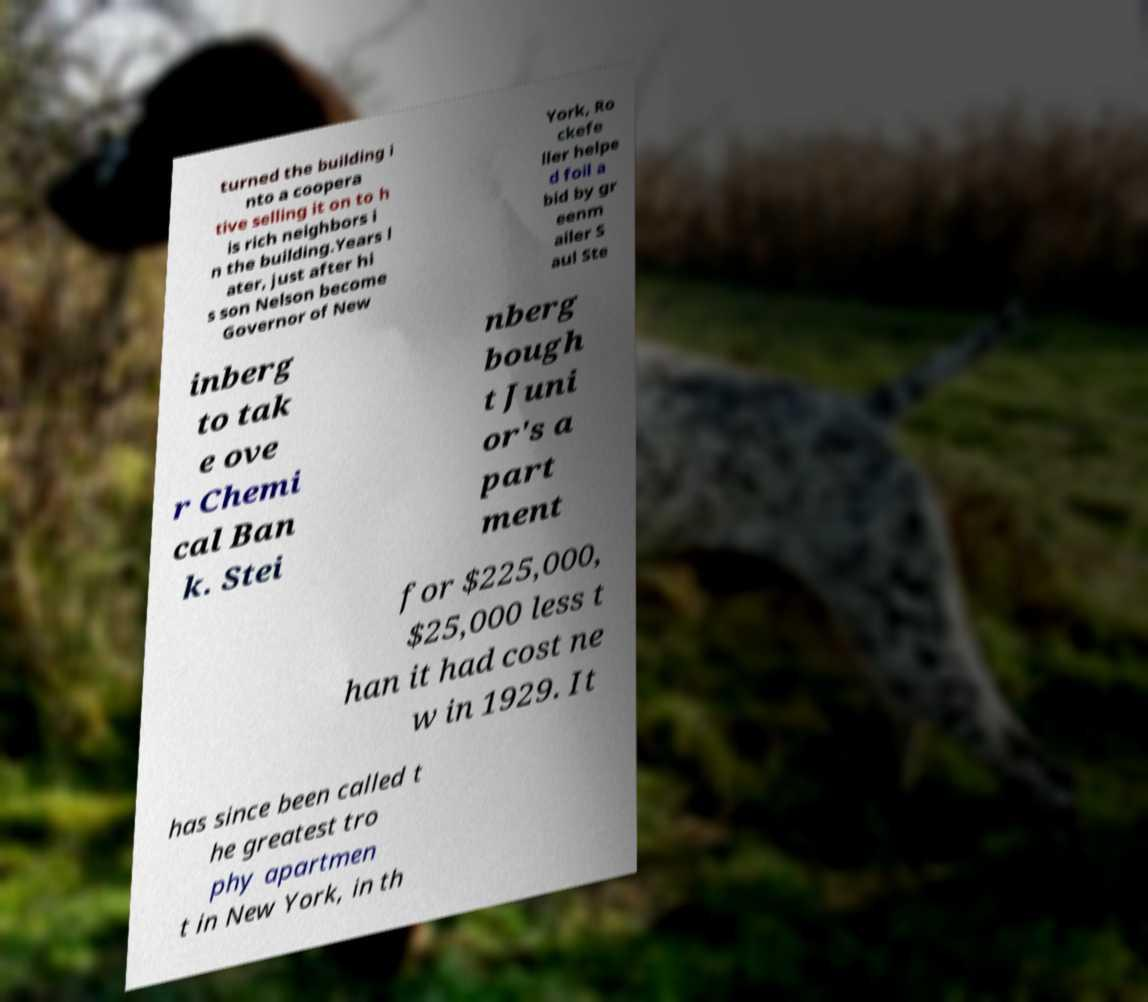There's text embedded in this image that I need extracted. Can you transcribe it verbatim? turned the building i nto a coopera tive selling it on to h is rich neighbors i n the building.Years l ater, just after hi s son Nelson become Governor of New York, Ro ckefe ller helpe d foil a bid by gr eenm ailer S aul Ste inberg to tak e ove r Chemi cal Ban k. Stei nberg bough t Juni or's a part ment for $225,000, $25,000 less t han it had cost ne w in 1929. It has since been called t he greatest tro phy apartmen t in New York, in th 